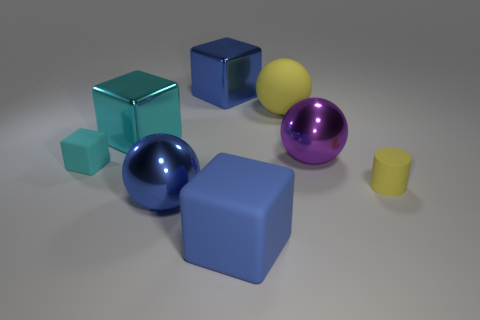The blue metallic object that is the same shape as the small cyan object is what size?
Offer a very short reply. Large. What is the big blue cube that is behind the yellow cylinder made of?
Provide a succinct answer. Metal. What number of metallic things are either big blue objects or tiny objects?
Your answer should be very brief. 2. Is there a cube of the same size as the cyan metallic object?
Your response must be concise. Yes. Is the number of matte cylinders that are to the left of the big yellow thing greater than the number of rubber things?
Provide a short and direct response. No. How many big objects are either blue shiny balls or purple shiny objects?
Your answer should be compact. 2. What number of other things are the same shape as the large yellow object?
Offer a terse response. 2. What material is the blue block behind the blue block that is in front of the yellow ball made of?
Your answer should be very brief. Metal. What is the size of the yellow matte thing to the left of the large purple metallic sphere?
Provide a short and direct response. Large. How many blue objects are either big matte blocks or big spheres?
Your response must be concise. 2. 